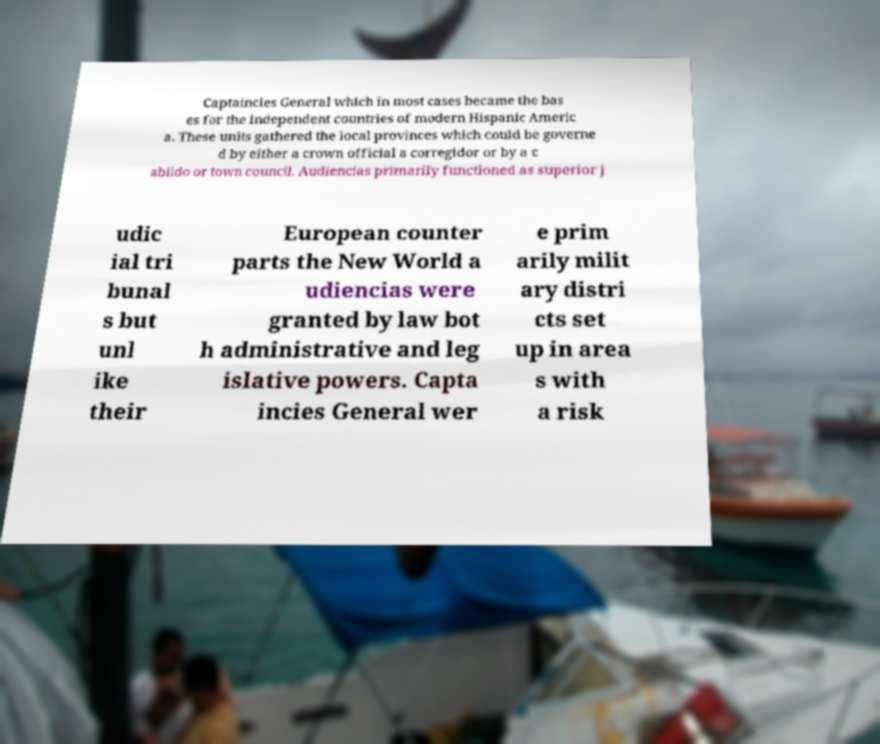For documentation purposes, I need the text within this image transcribed. Could you provide that? Captaincies General which in most cases became the bas es for the independent countries of modern Hispanic Americ a. These units gathered the local provinces which could be governe d by either a crown official a corregidor or by a c abildo or town council. Audiencias primarily functioned as superior j udic ial tri bunal s but unl ike their European counter parts the New World a udiencias were granted by law bot h administrative and leg islative powers. Capta incies General wer e prim arily milit ary distri cts set up in area s with a risk 